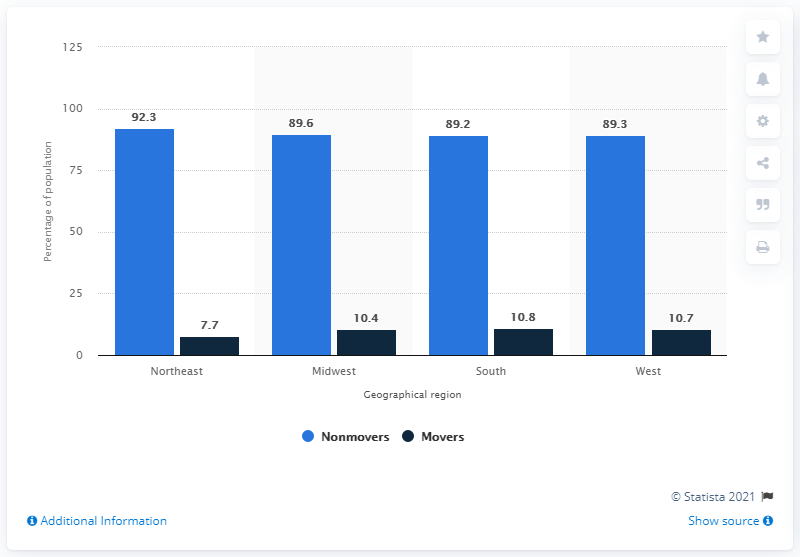Draw attention to some important aspects in this diagram. The sum of the greatest and the smallest differences between nonmovers and movers across all regions is 163.2.. The navy blue bar represents movers, specifically those who have recently moved into a new home or apartment. 